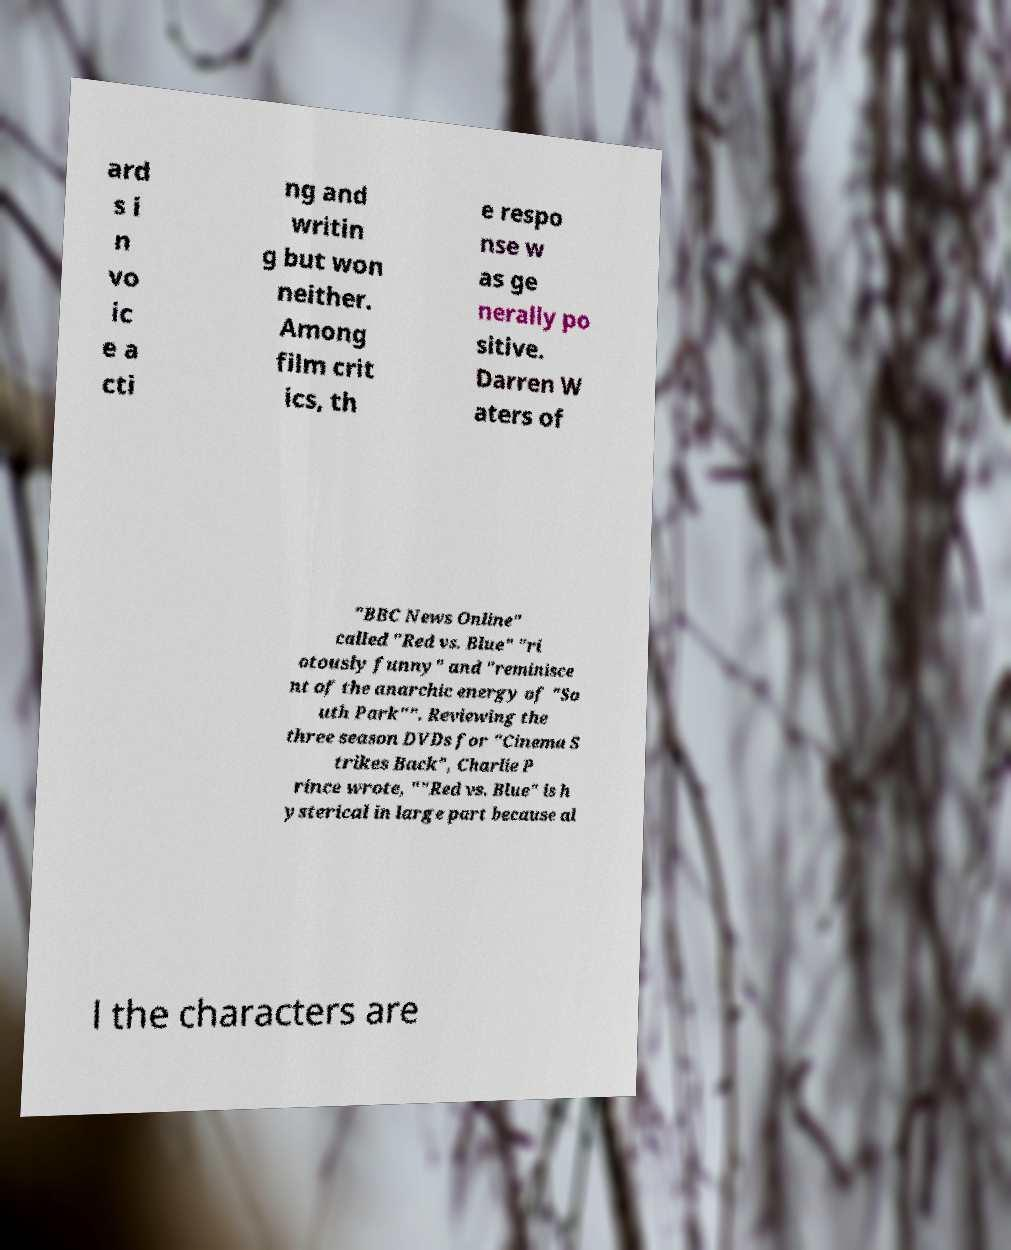Can you read and provide the text displayed in the image?This photo seems to have some interesting text. Can you extract and type it out for me? ard s i n vo ic e a cti ng and writin g but won neither. Among film crit ics, th e respo nse w as ge nerally po sitive. Darren W aters of "BBC News Online" called "Red vs. Blue" "ri otously funny" and "reminisce nt of the anarchic energy of "So uth Park"". Reviewing the three season DVDs for "Cinema S trikes Back", Charlie P rince wrote, ""Red vs. Blue" is h ysterical in large part because al l the characters are 